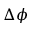Convert formula to latex. <formula><loc_0><loc_0><loc_500><loc_500>\Delta \phi</formula> 